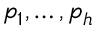<formula> <loc_0><loc_0><loc_500><loc_500>p _ { 1 } , \dots , p _ { h }</formula> 